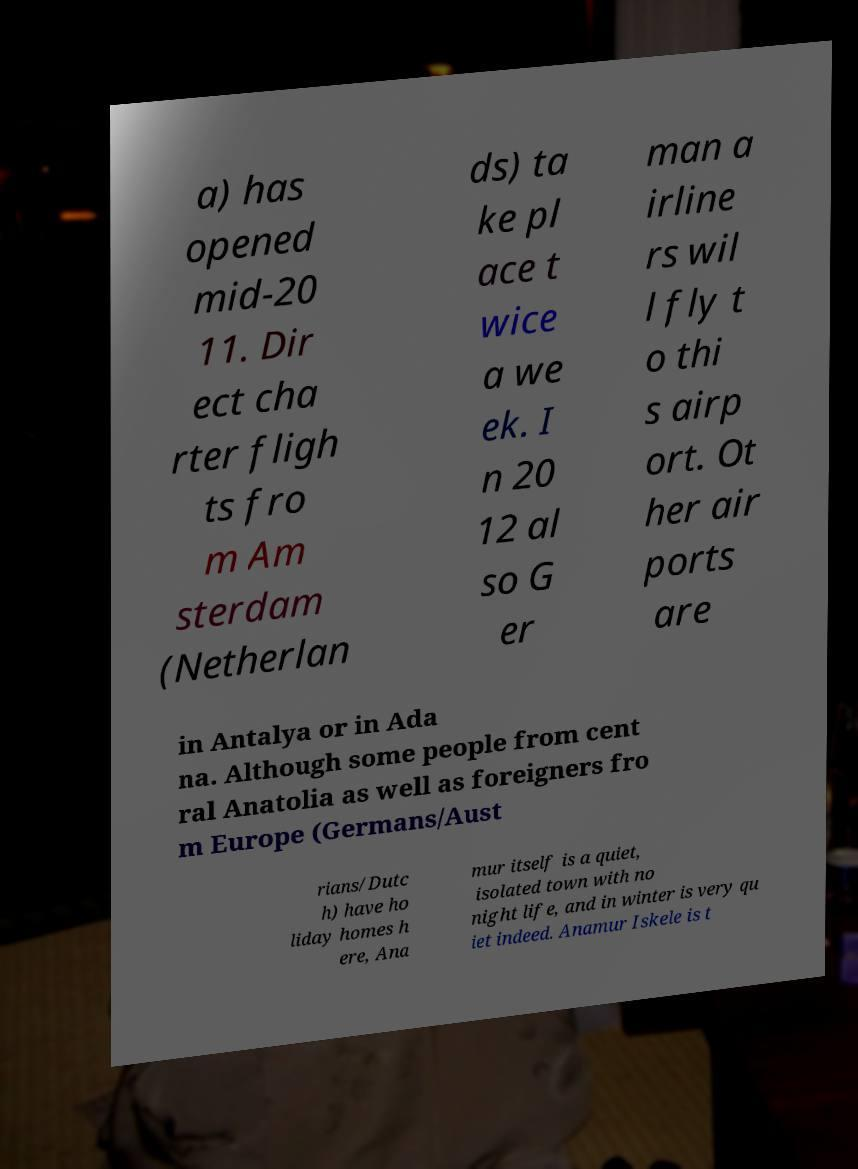Can you accurately transcribe the text from the provided image for me? a) has opened mid-20 11. Dir ect cha rter fligh ts fro m Am sterdam (Netherlan ds) ta ke pl ace t wice a we ek. I n 20 12 al so G er man a irline rs wil l fly t o thi s airp ort. Ot her air ports are in Antalya or in Ada na. Although some people from cent ral Anatolia as well as foreigners fro m Europe (Germans/Aust rians/Dutc h) have ho liday homes h ere, Ana mur itself is a quiet, isolated town with no night life, and in winter is very qu iet indeed. Anamur Iskele is t 